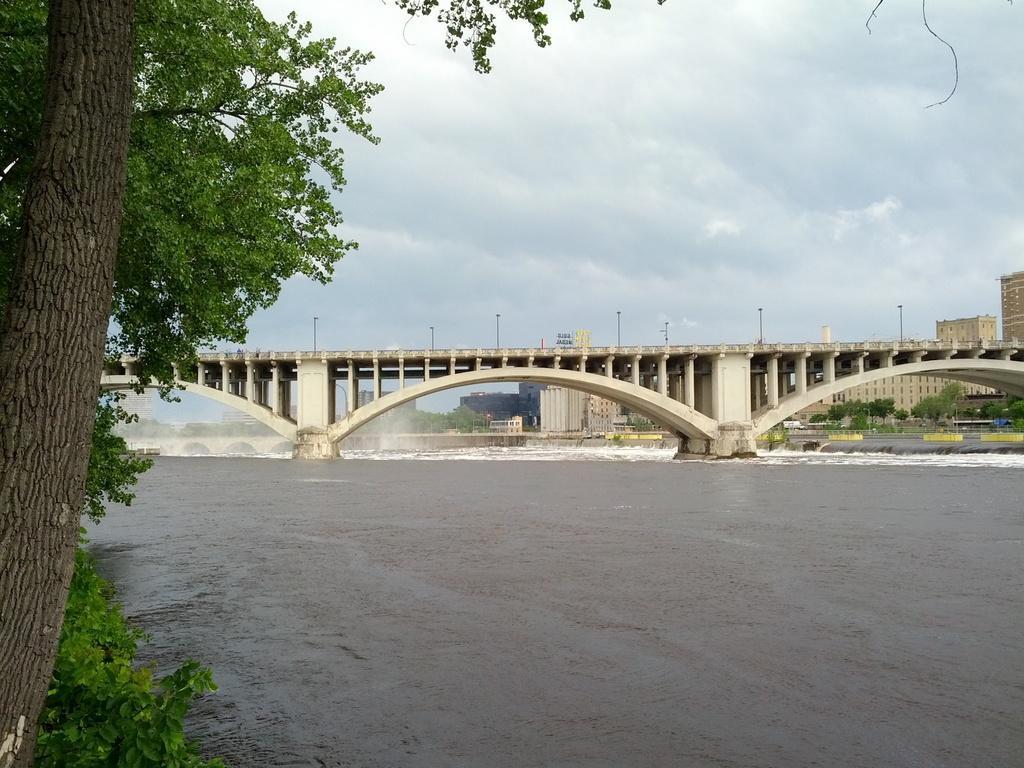Can you describe this image briefly? In the background we can see buildings, trees. We can see a bridge. At the bottom portion of the picture we can see water. On the left side of the picture we can see trees. 